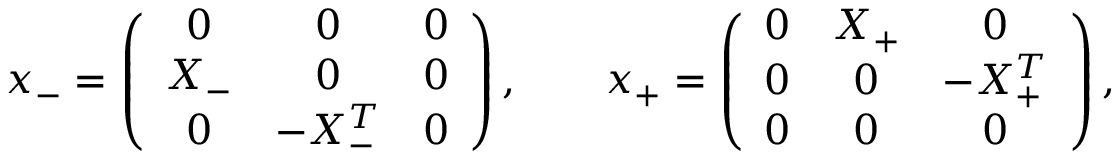<formula> <loc_0><loc_0><loc_500><loc_500>x _ { - } = \left ( \begin{array} { c c c } { 0 } & { 0 } & { 0 } \\ { { X _ { - } } } & { 0 } & { 0 } \\ { 0 } & { { - X _ { - } ^ { T } } } & { 0 } \end{array} \right ) , \quad x _ { + } = \left ( \begin{array} { c c c } { 0 } & { { X _ { + } } } & { 0 } \\ { 0 } & { 0 } & { { - X _ { + } ^ { T } } } \\ { 0 } & { 0 } & { 0 } \end{array} \right ) ,</formula> 